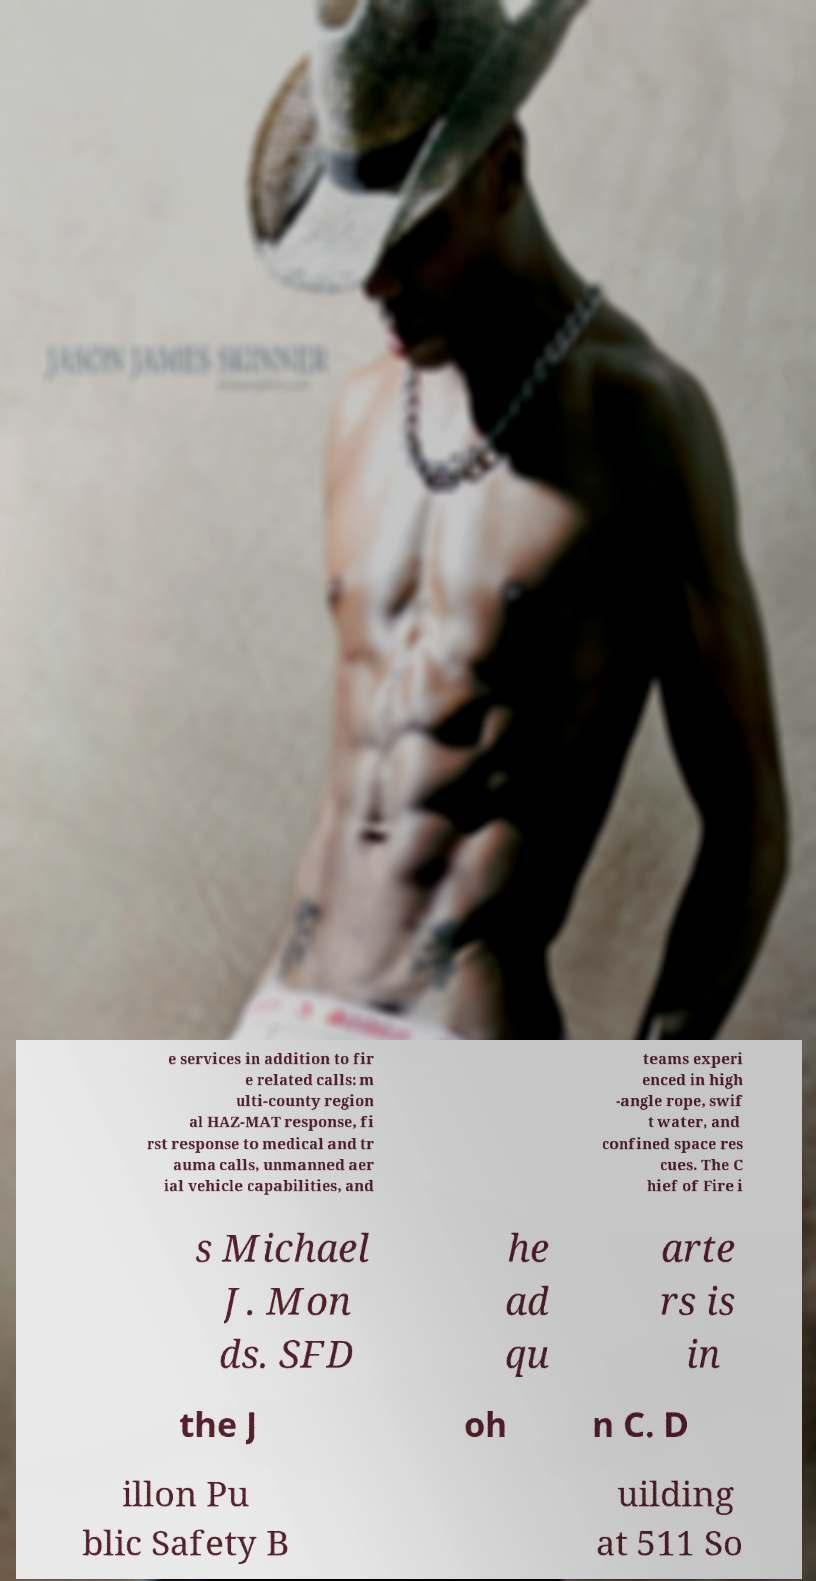For documentation purposes, I need the text within this image transcribed. Could you provide that? e services in addition to fir e related calls: m ulti-county region al HAZ-MAT response, fi rst response to medical and tr auma calls, unmanned aer ial vehicle capabilities, and teams experi enced in high -angle rope, swif t water, and confined space res cues. The C hief of Fire i s Michael J. Mon ds. SFD he ad qu arte rs is in the J oh n C. D illon Pu blic Safety B uilding at 511 So 